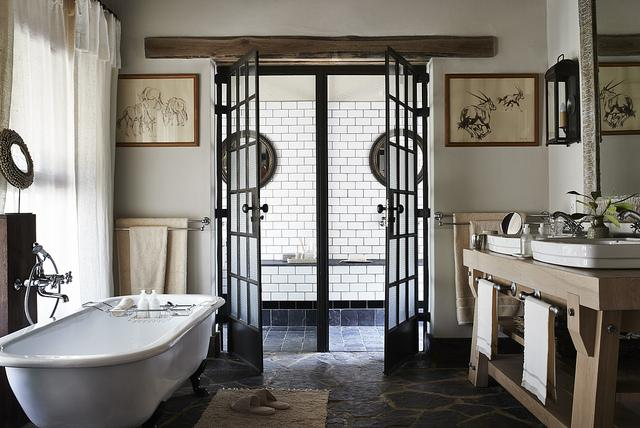The floor of the bathroom is made of what material? stone 